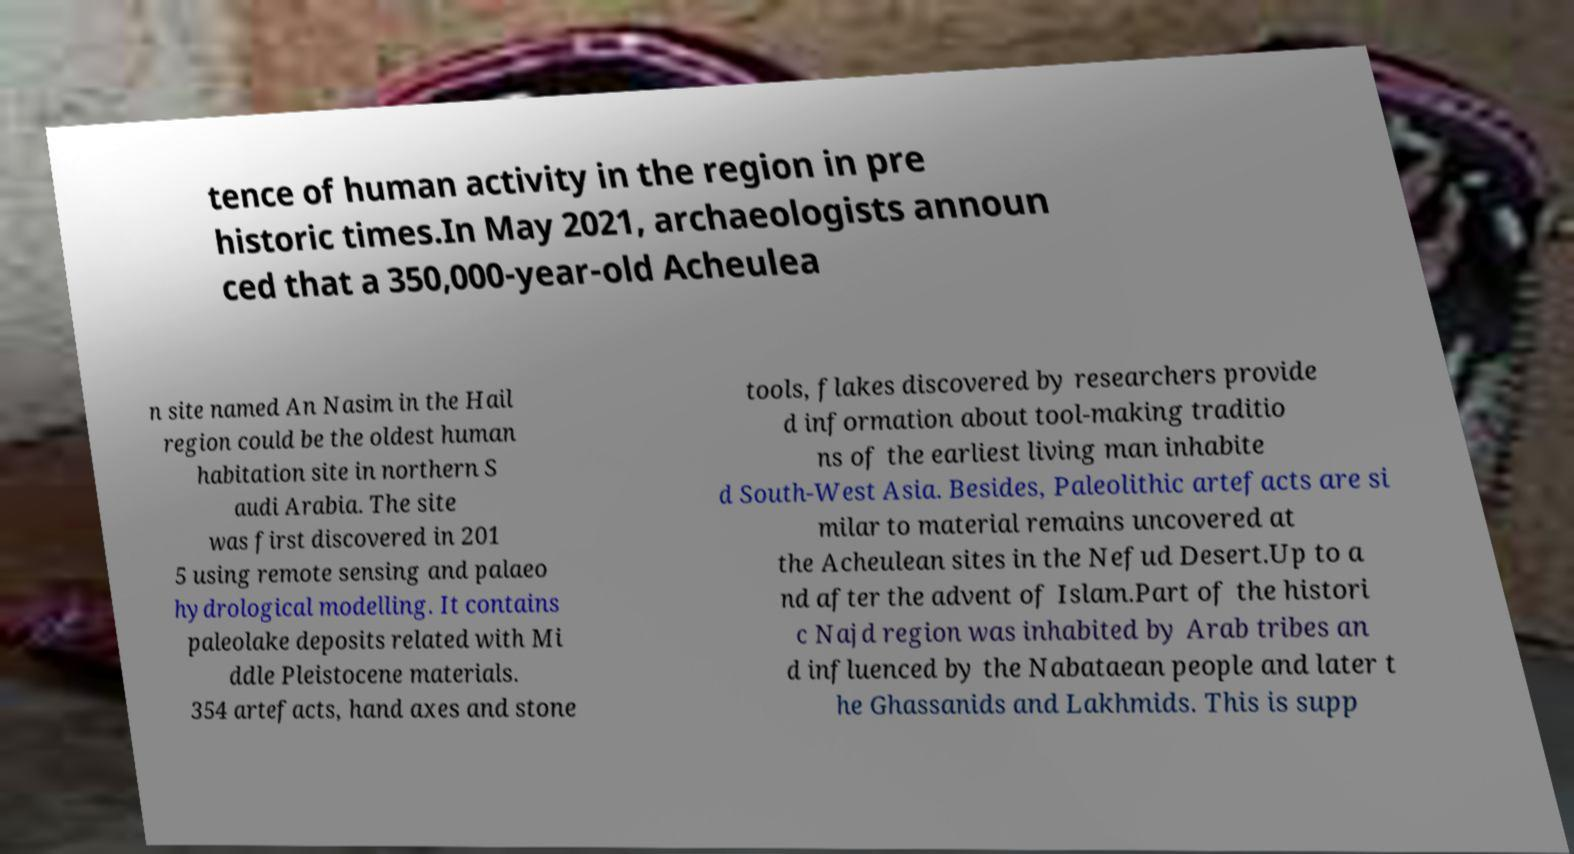Could you extract and type out the text from this image? tence of human activity in the region in pre historic times.In May 2021, archaeologists announ ced that a 350,000-year-old Acheulea n site named An Nasim in the Hail region could be the oldest human habitation site in northern S audi Arabia. The site was first discovered in 201 5 using remote sensing and palaeo hydrological modelling. It contains paleolake deposits related with Mi ddle Pleistocene materials. 354 artefacts, hand axes and stone tools, flakes discovered by researchers provide d information about tool-making traditio ns of the earliest living man inhabite d South-West Asia. Besides, Paleolithic artefacts are si milar to material remains uncovered at the Acheulean sites in the Nefud Desert.Up to a nd after the advent of Islam.Part of the histori c Najd region was inhabited by Arab tribes an d influenced by the Nabataean people and later t he Ghassanids and Lakhmids. This is supp 